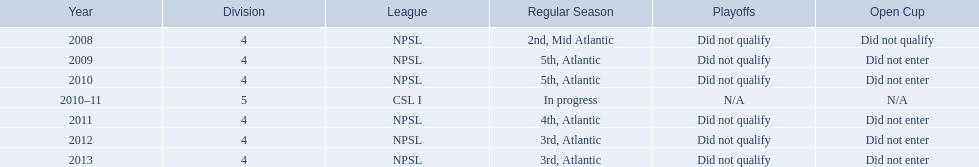What are the various leagues? NPSL, NPSL, NPSL, CSL I, NPSL, NPSL, NPSL. Which one had the fewest games played? CSL I. What are the various league names? NPSL, CSL I. In which league, other than npsl, has the ny soccer team played? CSL I. Can you give me this table as a dict? {'header': ['Year', 'Division', 'League', 'Regular Season', 'Playoffs', 'Open Cup'], 'rows': [['2008', '4', 'NPSL', '2nd, Mid Atlantic', 'Did not qualify', 'Did not qualify'], ['2009', '4', 'NPSL', '5th, Atlantic', 'Did not qualify', 'Did not enter'], ['2010', '4', 'NPSL', '5th, Atlantic', 'Did not qualify', 'Did not enter'], ['2010–11', '5', 'CSL I', 'In progress', 'N/A', 'N/A'], ['2011', '4', 'NPSL', '4th, Atlantic', 'Did not qualify', 'Did not enter'], ['2012', '4', 'NPSL', '3rd, Atlantic', 'Did not qualify', 'Did not enter'], ['2013', '4', 'NPSL', '3rd, Atlantic', 'Did not qualify', 'Did not enter']]} 